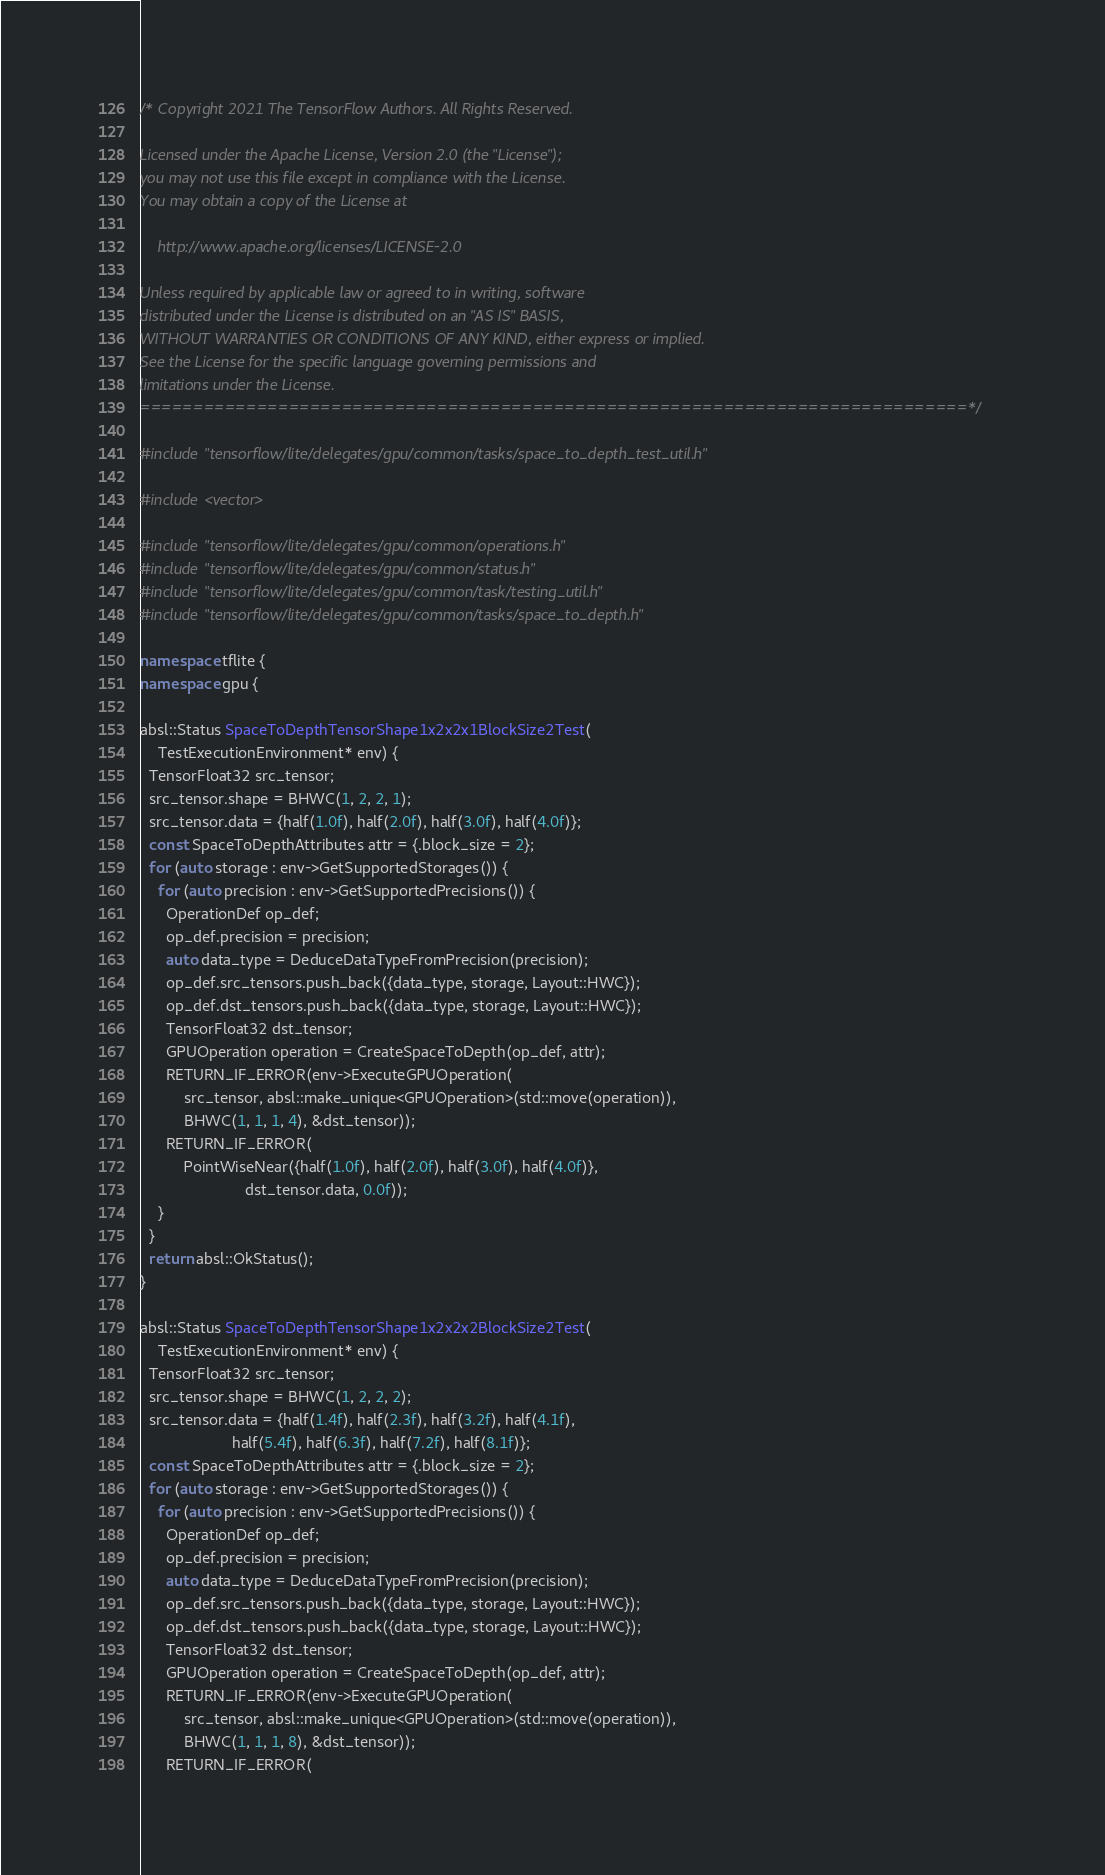Convert code to text. <code><loc_0><loc_0><loc_500><loc_500><_C++_>/* Copyright 2021 The TensorFlow Authors. All Rights Reserved.

Licensed under the Apache License, Version 2.0 (the "License");
you may not use this file except in compliance with the License.
You may obtain a copy of the License at

    http://www.apache.org/licenses/LICENSE-2.0

Unless required by applicable law or agreed to in writing, software
distributed under the License is distributed on an "AS IS" BASIS,
WITHOUT WARRANTIES OR CONDITIONS OF ANY KIND, either express or implied.
See the License for the specific language governing permissions and
limitations under the License.
==============================================================================*/

#include "tensorflow/lite/delegates/gpu/common/tasks/space_to_depth_test_util.h"

#include <vector>

#include "tensorflow/lite/delegates/gpu/common/operations.h"
#include "tensorflow/lite/delegates/gpu/common/status.h"
#include "tensorflow/lite/delegates/gpu/common/task/testing_util.h"
#include "tensorflow/lite/delegates/gpu/common/tasks/space_to_depth.h"

namespace tflite {
namespace gpu {

absl::Status SpaceToDepthTensorShape1x2x2x1BlockSize2Test(
    TestExecutionEnvironment* env) {
  TensorFloat32 src_tensor;
  src_tensor.shape = BHWC(1, 2, 2, 1);
  src_tensor.data = {half(1.0f), half(2.0f), half(3.0f), half(4.0f)};
  const SpaceToDepthAttributes attr = {.block_size = 2};
  for (auto storage : env->GetSupportedStorages()) {
    for (auto precision : env->GetSupportedPrecisions()) {
      OperationDef op_def;
      op_def.precision = precision;
      auto data_type = DeduceDataTypeFromPrecision(precision);
      op_def.src_tensors.push_back({data_type, storage, Layout::HWC});
      op_def.dst_tensors.push_back({data_type, storage, Layout::HWC});
      TensorFloat32 dst_tensor;
      GPUOperation operation = CreateSpaceToDepth(op_def, attr);
      RETURN_IF_ERROR(env->ExecuteGPUOperation(
          src_tensor, absl::make_unique<GPUOperation>(std::move(operation)),
          BHWC(1, 1, 1, 4), &dst_tensor));
      RETURN_IF_ERROR(
          PointWiseNear({half(1.0f), half(2.0f), half(3.0f), half(4.0f)},
                        dst_tensor.data, 0.0f));
    }
  }
  return absl::OkStatus();
}

absl::Status SpaceToDepthTensorShape1x2x2x2BlockSize2Test(
    TestExecutionEnvironment* env) {
  TensorFloat32 src_tensor;
  src_tensor.shape = BHWC(1, 2, 2, 2);
  src_tensor.data = {half(1.4f), half(2.3f), half(3.2f), half(4.1f),
                     half(5.4f), half(6.3f), half(7.2f), half(8.1f)};
  const SpaceToDepthAttributes attr = {.block_size = 2};
  for (auto storage : env->GetSupportedStorages()) {
    for (auto precision : env->GetSupportedPrecisions()) {
      OperationDef op_def;
      op_def.precision = precision;
      auto data_type = DeduceDataTypeFromPrecision(precision);
      op_def.src_tensors.push_back({data_type, storage, Layout::HWC});
      op_def.dst_tensors.push_back({data_type, storage, Layout::HWC});
      TensorFloat32 dst_tensor;
      GPUOperation operation = CreateSpaceToDepth(op_def, attr);
      RETURN_IF_ERROR(env->ExecuteGPUOperation(
          src_tensor, absl::make_unique<GPUOperation>(std::move(operation)),
          BHWC(1, 1, 1, 8), &dst_tensor));
      RETURN_IF_ERROR(</code> 